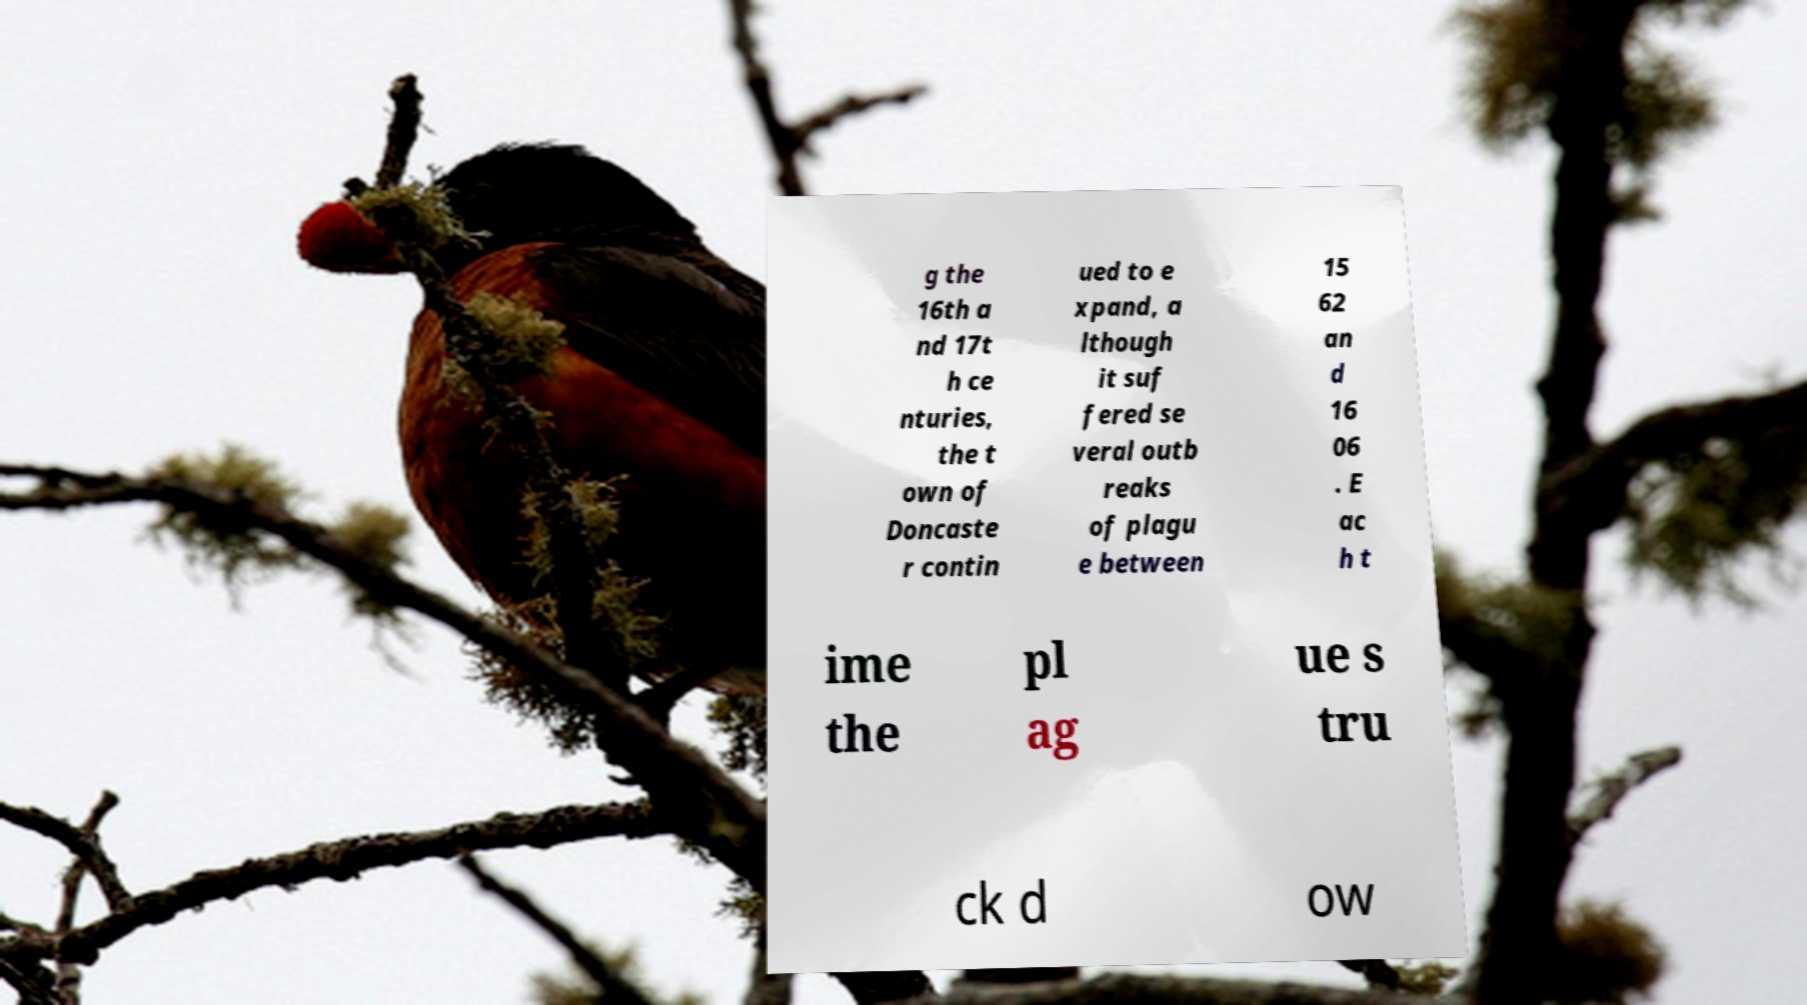Could you extract and type out the text from this image? g the 16th a nd 17t h ce nturies, the t own of Doncaste r contin ued to e xpand, a lthough it suf fered se veral outb reaks of plagu e between 15 62 an d 16 06 . E ac h t ime the pl ag ue s tru ck d ow 